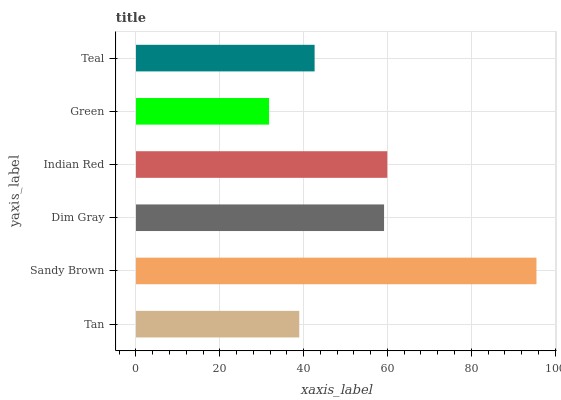Is Green the minimum?
Answer yes or no. Yes. Is Sandy Brown the maximum?
Answer yes or no. Yes. Is Dim Gray the minimum?
Answer yes or no. No. Is Dim Gray the maximum?
Answer yes or no. No. Is Sandy Brown greater than Dim Gray?
Answer yes or no. Yes. Is Dim Gray less than Sandy Brown?
Answer yes or no. Yes. Is Dim Gray greater than Sandy Brown?
Answer yes or no. No. Is Sandy Brown less than Dim Gray?
Answer yes or no. No. Is Dim Gray the high median?
Answer yes or no. Yes. Is Teal the low median?
Answer yes or no. Yes. Is Green the high median?
Answer yes or no. No. Is Sandy Brown the low median?
Answer yes or no. No. 